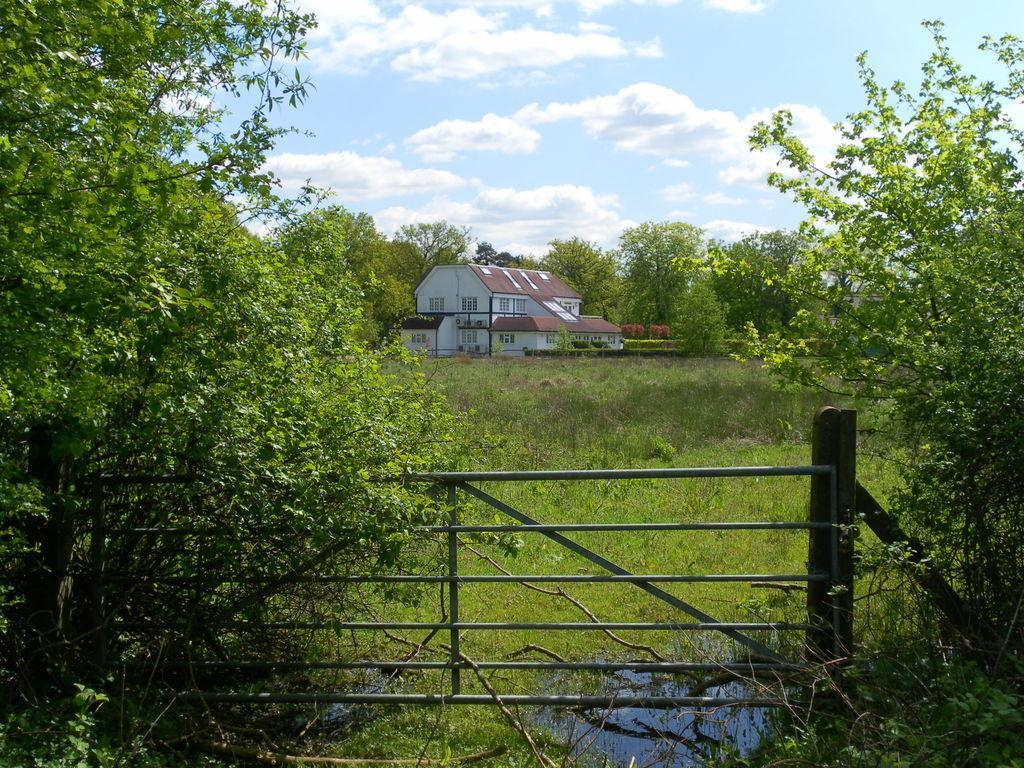How would you summarize this image in a sentence or two? In this image, we can see so many trees, plants, grass, water, rod fencing. Background we can see a bungalow with walls and windows. Top of the image, there is a cloudy sky. 